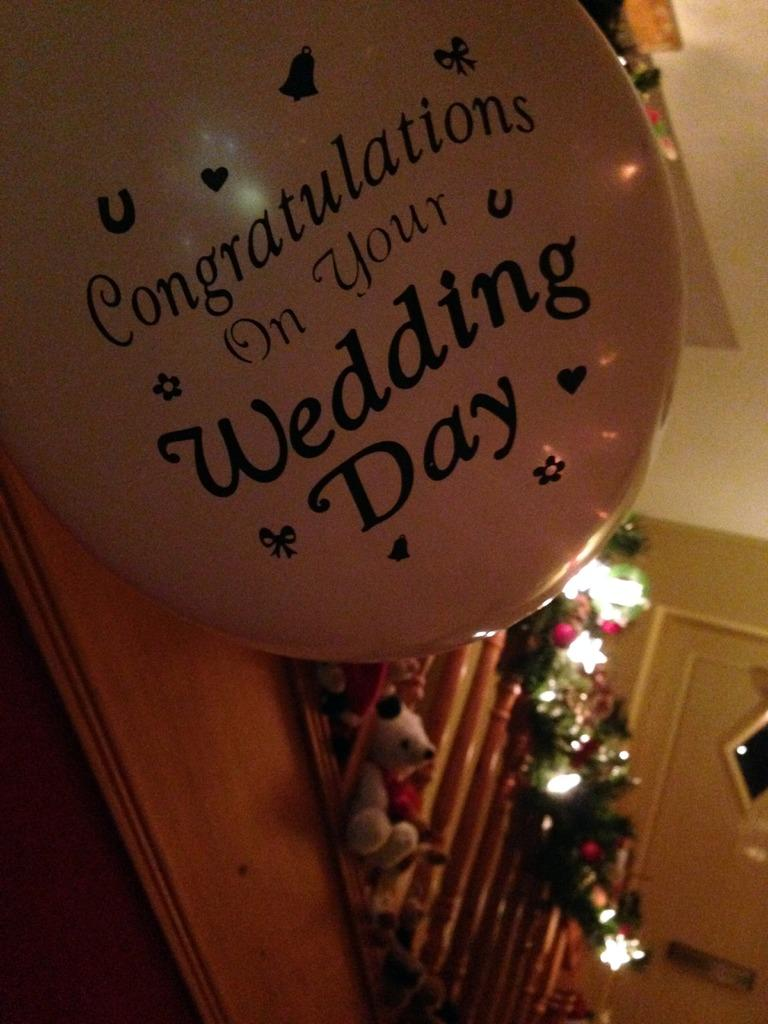What is located at the bottom of the image? There is a doll at the bottom of the image. What can be seen in the image besides the doll? There are lights and a balloon in the image. Where is the balloon positioned in the image? The balloon is at the top of the image. What is written on the balloon? The balloon has text on it. Can you see a knife cutting through the vein in the image? There is no knife or vein present in the image. What type of door is visible in the image? There is no door present in the image. 